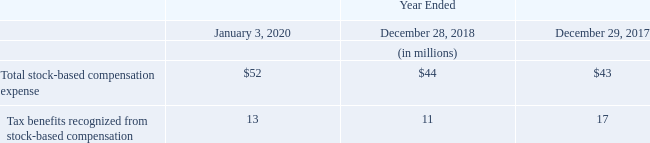Plan Summaries
As of January 3, 2020, the Company had stock-based compensation awards outstanding under the following plans: the 2017 Omnibus Incentive Plan, 2006 Equity Incentive Plan, as amended, and the 2006 Employee Stock Purchase Plan, as amended ("ESPP"). Leidos issues new shares upon the issuance of the vesting of stock units or exercising of stock options under these plans.
In fiscal 2017, stockholders approved the 2017 Omnibus Incentive Plan which provides the Company and its affiliates' employees, directors and consultants the opportunity to receive various types of stock-based compensation awards, such as stock options, restricted stock units and performance-based awards, as well as cash awards.
The Company grants service-based awards that generally vest or become exercisable 25% a year over four years or cliff vest in three years. As of January 3, 2020, 4.4 million shares of Leidos' stock were reserved for future issuance under the 2017 Omnibus Incentive Plan and the 2006 Equity Incentive Plan.
The Company offers eligible employees the opportunity to defer restricted stock units into an equity-based deferred equity compensation plan, the Key Executive Stock Deferral Plan ("KESDP"). Prior to 2013, the Company offered an additional opportunity for deferrals into the Management Stock Compensation Plan ("MSCP"). Benefits from these plans are payable in shares of Leidos' stock that are held in a trust for the purpose of funding shares to the plans' participants.
Restricted stock units deferred under the KESDP are counted against the total shares available for future issuance under the 2017 Omnibus Incentive Plan. All awards under the MSCP are fully vested and the plan does not provide for a maximum number of shares available for future issuance.
The Company's ESPP allows eligible employees to purchase shares of Leidos' stock at a discount of up to 15% of the fair market value on the date of purchase. During the first half of fiscal 2018 and 2017, the discount was 5% of the fair market value on the date of purchase, thereby resulting in the ESPP being non-compensatory. Effective the second half of fiscal 2018, the Company increased the discount to 10% of the fair market value on the date of purchase, resulting in the ESPP being compensatory.
During fiscal 2019, 2018 and 2017, $25 million, $11 million and $10 million, respectively, was received from ESPP plan participants for the issuance of Leidos' stock. A total of 4.2 million shares remain available for future issuance under the ESPP.
Stock-based compensation and related tax benefits recognized under all plans were as follows:
What was the 2017 Omnibus Incentive Plan? Provides the company and its affiliates' employees, directors and consultants the opportunity to receive various types of stock-based compensation awards, such as stock options, restricted stock units and performance-based awards, as well as cash awards. What was the number of Leidos' stock were reserved for future issuance under the 2017 Omnibus Incentive Plan and the 2006 Equity Incentive Plan? 4.4 million. What was the Total stock-based compensation expense in 2020, 2018 and 2017 respectively?
Answer scale should be: million. $52, $44, $43. In which year was Total stock-based compensation expense less than 50 million? Locate and analyze total stock-based compensation expense in row 5
answer: 2018, 2017. What was the average Total stock-based compensation expense in 2018 and 2017?
Answer scale should be: million. (44 + 43) / 2
Answer: 43.5. What was the change in the Tax benefits recognized from stock-based compensation from 2017 to 2018?
Answer scale should be: million. 11 - 17
Answer: -6. 